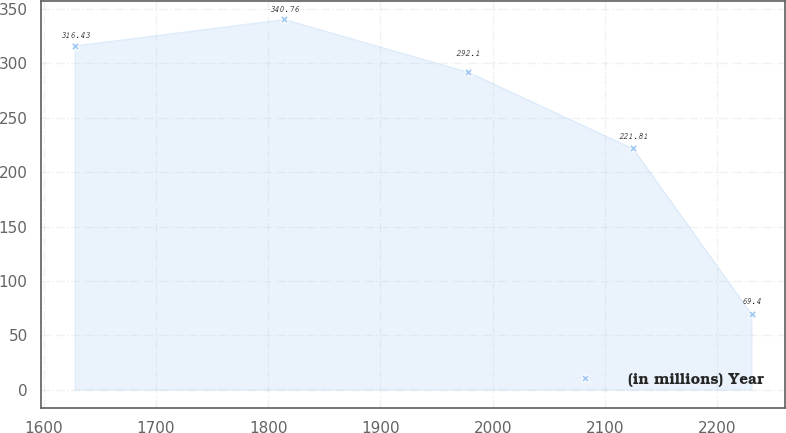<chart> <loc_0><loc_0><loc_500><loc_500><line_chart><ecel><fcel>(in millions) Year<nl><fcel>1627.73<fcel>316.43<nl><fcel>1814.18<fcel>340.76<nl><fcel>1978.25<fcel>292.1<nl><fcel>2124.88<fcel>221.81<nl><fcel>2230.52<fcel>69.4<nl></chart> 